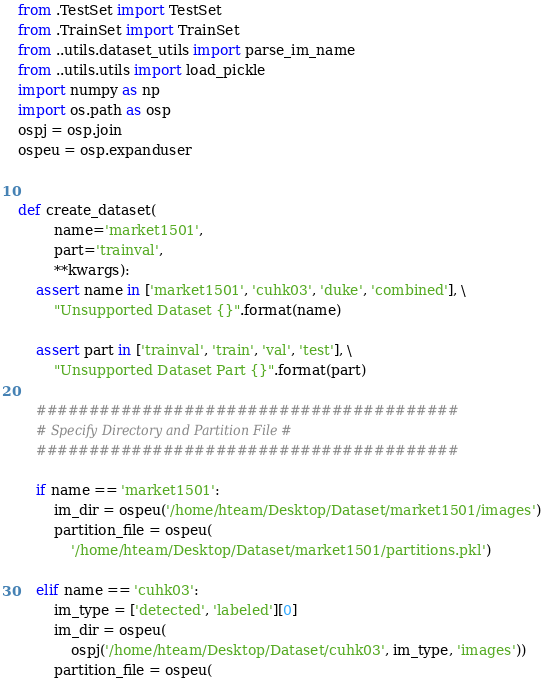<code> <loc_0><loc_0><loc_500><loc_500><_Python_>from .TestSet import TestSet
from .TrainSet import TrainSet
from ..utils.dataset_utils import parse_im_name
from ..utils.utils import load_pickle
import numpy as np
import os.path as osp
ospj = osp.join
ospeu = osp.expanduser


def create_dataset(
        name='market1501',
        part='trainval',
        **kwargs):
    assert name in ['market1501', 'cuhk03', 'duke', 'combined'], \
        "Unsupported Dataset {}".format(name)

    assert part in ['trainval', 'train', 'val', 'test'], \
        "Unsupported Dataset Part {}".format(part)

    ########################################
    # Specify Directory and Partition File #
    ########################################

    if name == 'market1501':
        im_dir = ospeu('/home/hteam/Desktop/Dataset/market1501/images')
        partition_file = ospeu(
            '/home/hteam/Desktop/Dataset/market1501/partitions.pkl')

    elif name == 'cuhk03':
        im_type = ['detected', 'labeled'][0]
        im_dir = ospeu(
            ospj('/home/hteam/Desktop/Dataset/cuhk03', im_type, 'images'))
        partition_file = ospeu(</code> 